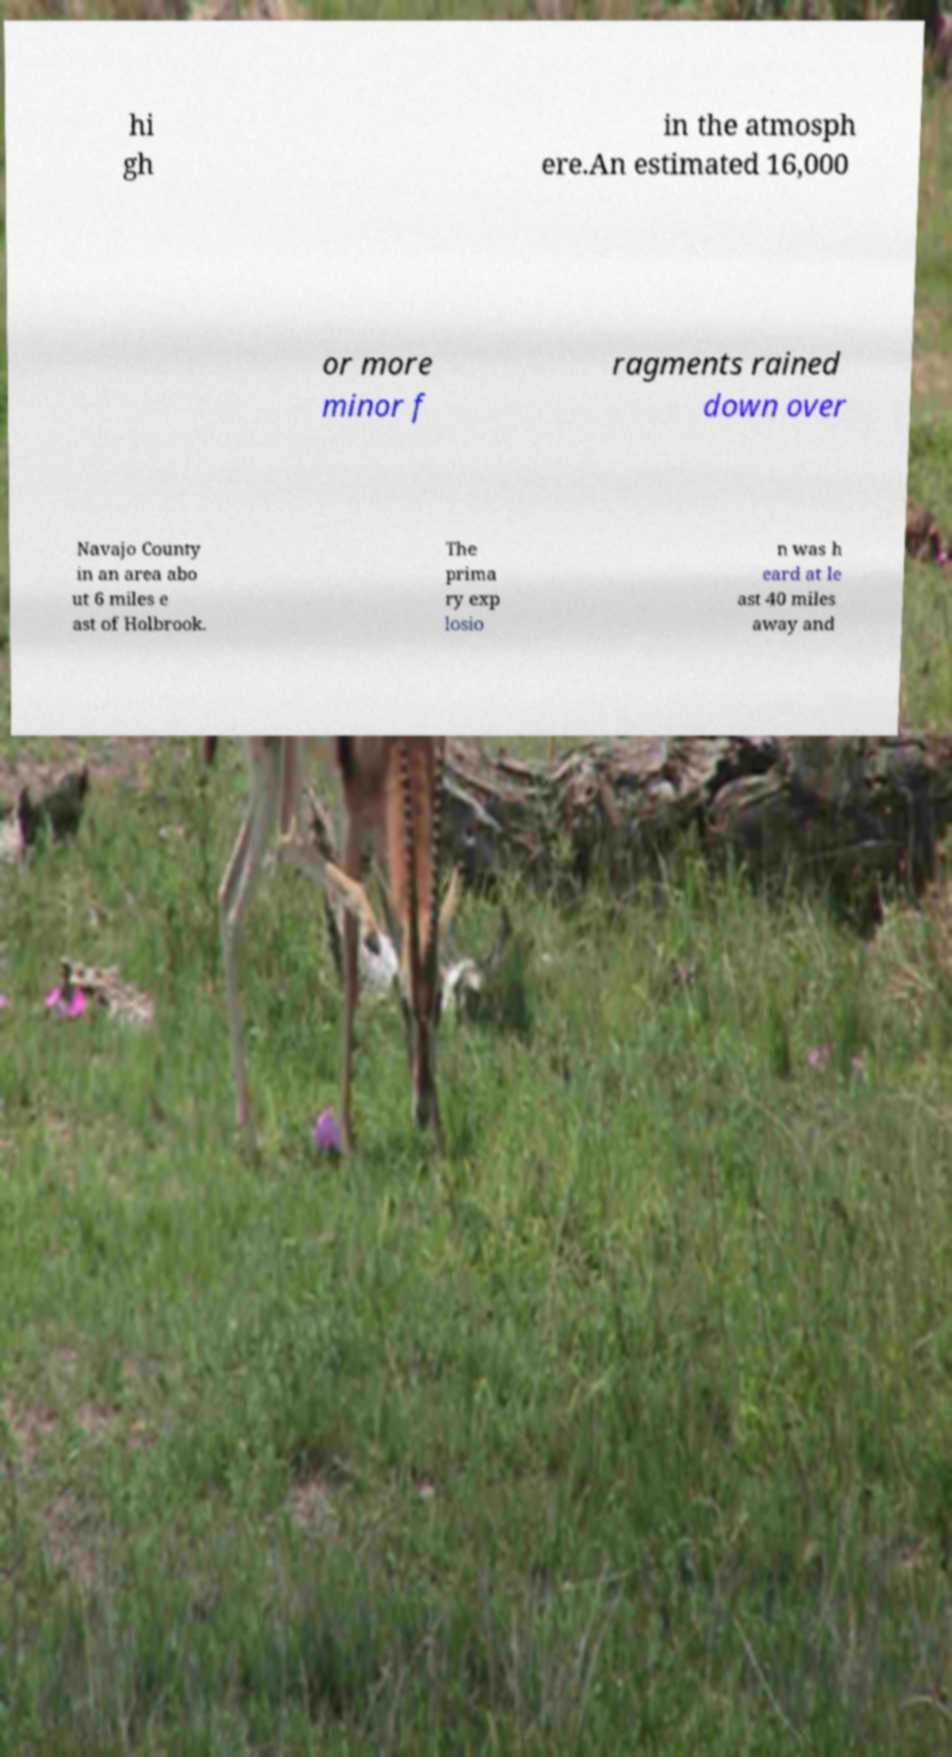Please read and relay the text visible in this image. What does it say? hi gh in the atmosph ere.An estimated 16,000 or more minor f ragments rained down over Navajo County in an area abo ut 6 miles e ast of Holbrook. The prima ry exp losio n was h eard at le ast 40 miles away and 